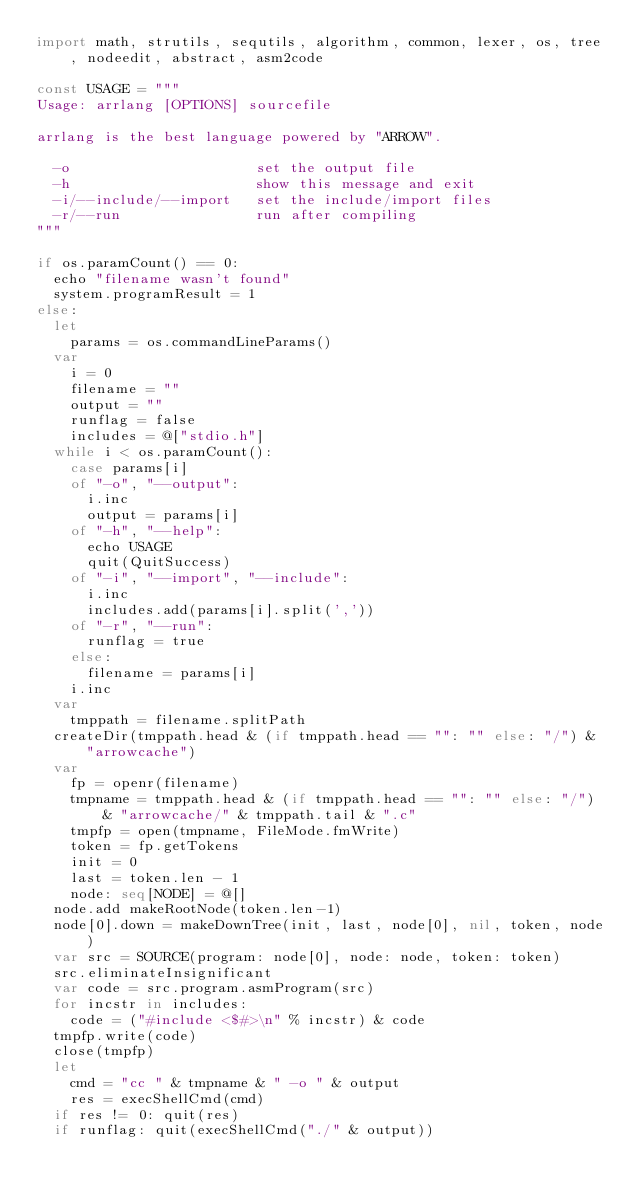<code> <loc_0><loc_0><loc_500><loc_500><_Nim_>import math, strutils, sequtils, algorithm, common, lexer, os, tree, nodeedit, abstract, asm2code

const USAGE = """
Usage: arrlang [OPTIONS] sourcefile

arrlang is the best language powered by "ARROW".

  -o                      set the output file
  -h                      show this message and exit
  -i/--include/--import   set the include/import files
  -r/--run                run after compiling
"""

if os.paramCount() == 0:
  echo "filename wasn't found"
  system.programResult = 1
else:
  let
    params = os.commandLineParams()
  var
    i = 0
    filename = ""
    output = ""
    runflag = false
    includes = @["stdio.h"]
  while i < os.paramCount():
    case params[i]
    of "-o", "--output":
      i.inc
      output = params[i]
    of "-h", "--help":
      echo USAGE
      quit(QuitSuccess)
    of "-i", "--import", "--include":
      i.inc
      includes.add(params[i].split(','))
    of "-r", "--run":
      runflag = true
    else:
      filename = params[i]
    i.inc
  var 
    tmppath = filename.splitPath
  createDir(tmppath.head & (if tmppath.head == "": "" else: "/") & "arrowcache")
  var
    fp = openr(filename)
    tmpname = tmppath.head & (if tmppath.head == "": "" else: "/") & "arrowcache/" & tmppath.tail & ".c"
    tmpfp = open(tmpname, FileMode.fmWrite)
    token = fp.getTokens
    init = 0
    last = token.len - 1
    node: seq[NODE] = @[]
  node.add makeRootNode(token.len-1)
  node[0].down = makeDownTree(init, last, node[0], nil, token, node)
  var src = SOURCE(program: node[0], node: node, token: token)
  src.eliminateInsignificant
  var code = src.program.asmProgram(src)
  for incstr in includes:
    code = ("#include <$#>\n" % incstr) & code
  tmpfp.write(code)
  close(tmpfp)
  let
    cmd = "cc " & tmpname & " -o " & output
    res = execShellCmd(cmd)
  if res != 0: quit(res)
  if runflag: quit(execShellCmd("./" & output))
</code> 